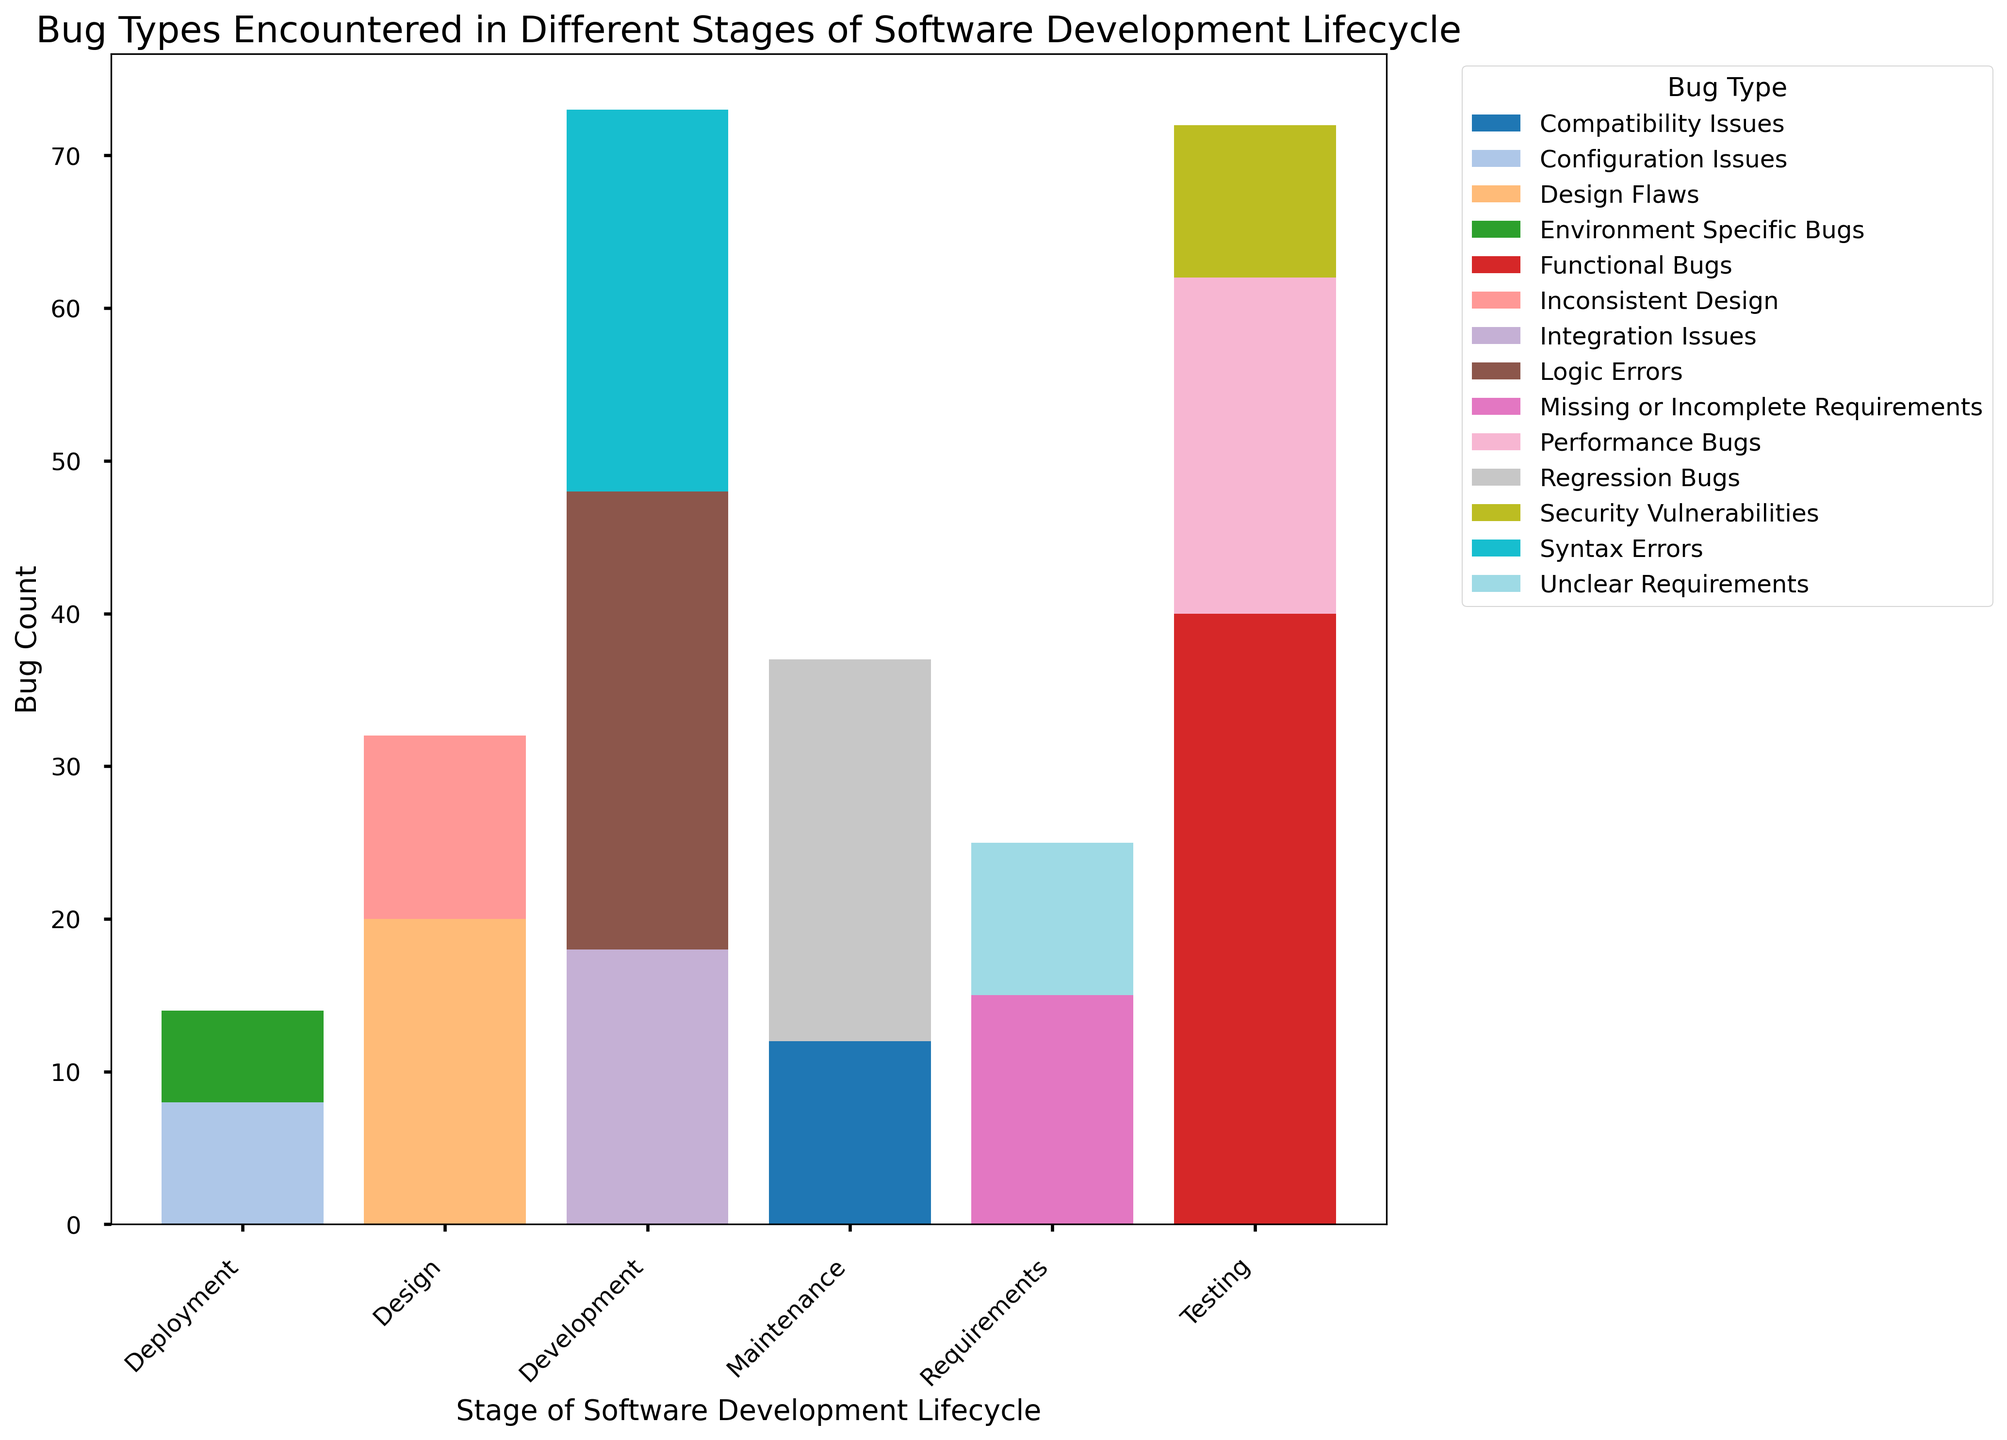What's the most common type of bug encountered during the Testing stage? The Testing stage shows three types of bugs: Functional Bugs, Performance Bugs, and Security Vulnerabilities. By comparing the heights of the bars, Functional Bugs clearly have the highest count.
Answer: Functional Bugs Which stage of the software development lifecycle encounters the least number of bugs overall? By summing the heights of the bars for each stage, Deployment has the lowest total count of bugs.
Answer: Deployment Are Syntax Errors more common than Logic Errors during Development? By comparing the heights of the bars for Syntax Errors and Logic Errors within the Development stage, Logic Errors have a taller bar than Syntax Errors.
Answer: No What is the combined count of Performance Bugs and Security Vulnerabilities during the Testing stage? In the Testing stage, the count of Performance Bugs (22) is added to the count of Security Vulnerabilities (10). The combined count is 22 + 10.
Answer: 32 How many more Logic Errors are there compared to Integration Issues during the Development stage? In the Development stage, Logic Errors have a count of 30 and Integration Issues have a count of 18. The difference is 30 - 18.
Answer: 12 Which stage has the highest number of Regression Bugs? By locating the bars for Regression Bugs in each stage, it is apparent that Regression Bugs are only encountered during the Maintenance stage.
Answer: Maintenance Does the total number of bugs during the Requirements stage exceed the total number of bugs in the Design stage? Summing the counts for each bug type in the Requirements stage (15 + 10 = 25) and comparing with the sum in the Design stage (20 + 12 = 32), the Design stage has a higher total.
Answer: No What is the average count of bugs for the Configuration Issues and Environment Specific Bugs during Deployment? The Deployment stage shows 8 Configuration Issues and 6 Environment Specific Bugs. Their average is calculated as (8 + 6) / 2 = 7.
Answer: 7 Is the number of Incomplete or Missing Requirements more than the number of Compatibility Issues during Maintenance? Comparing the counts, Incomplete or Missing Requirements have a count of 15, whereas Compatibility Issues have a count of 12. Therefore, 15 is greater than 12.
Answer: Yes 